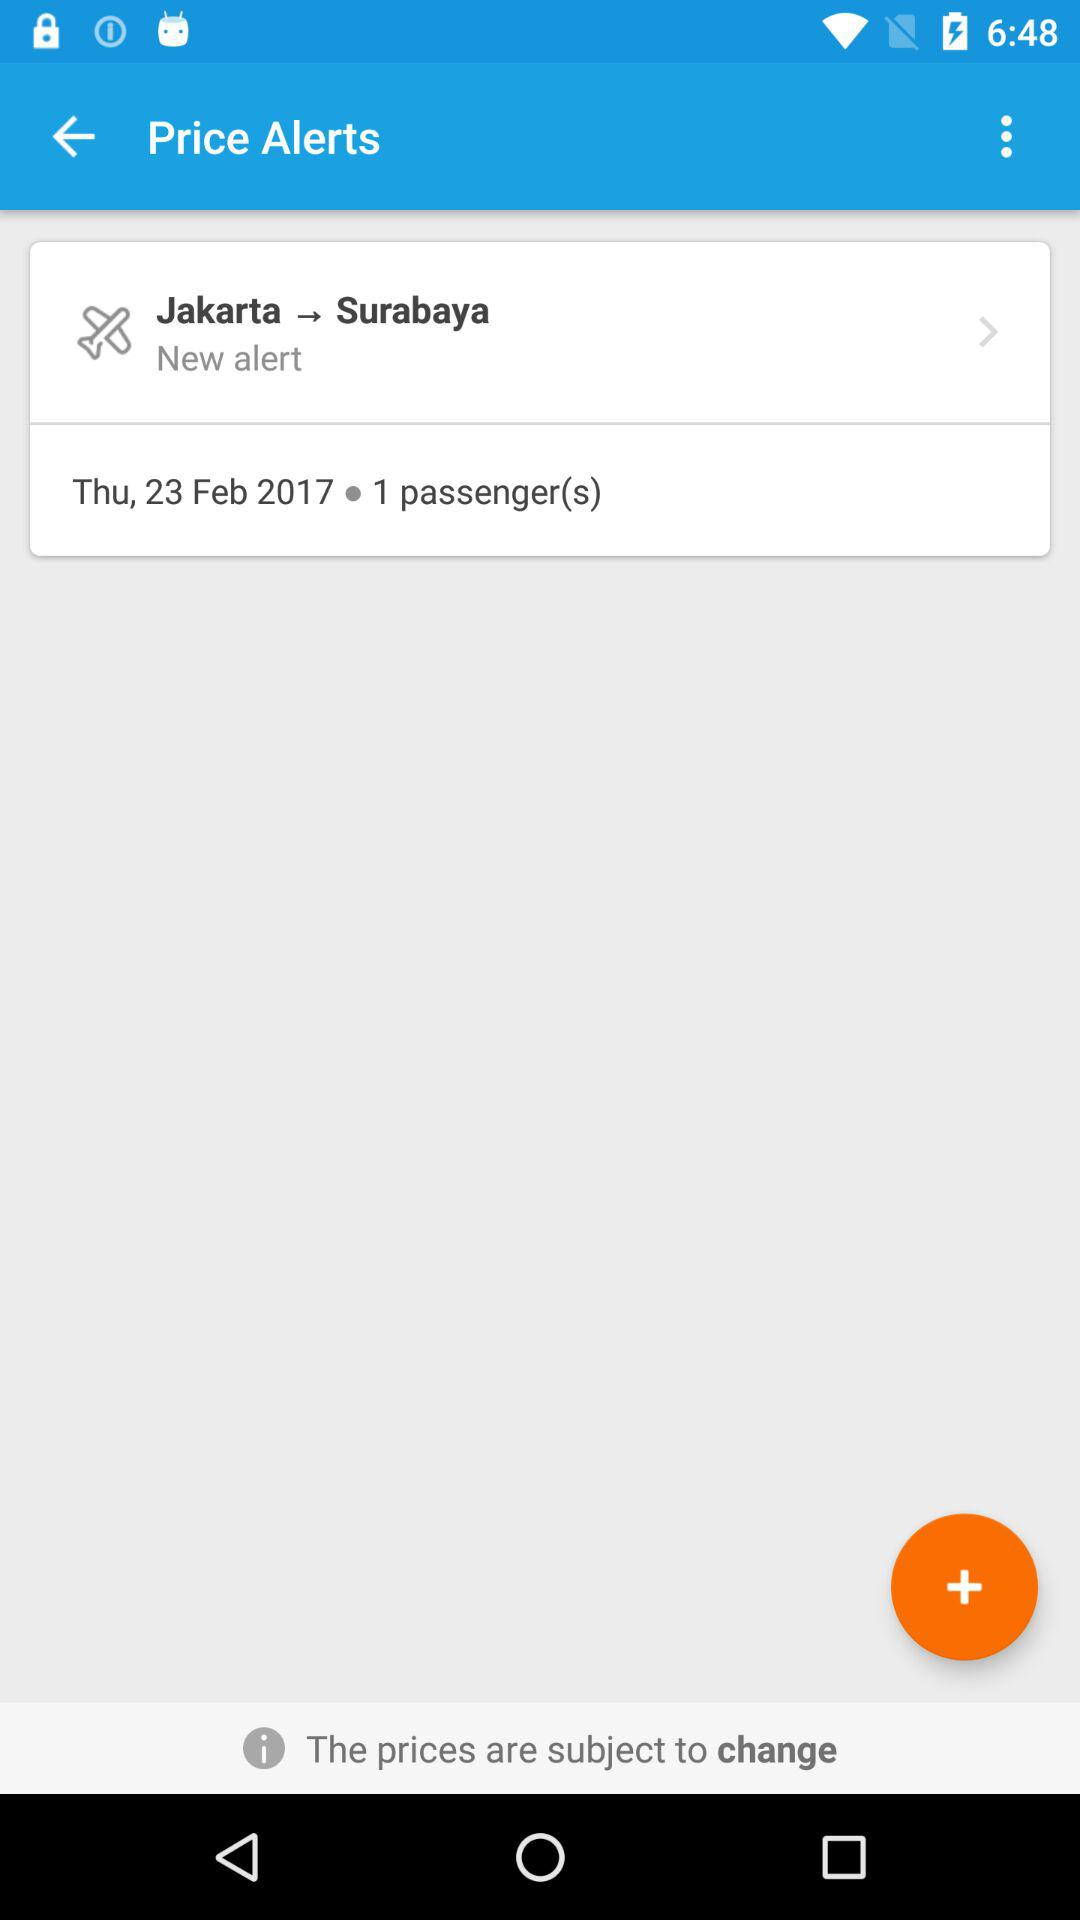How many passengers are there? There is 1 passenger. 